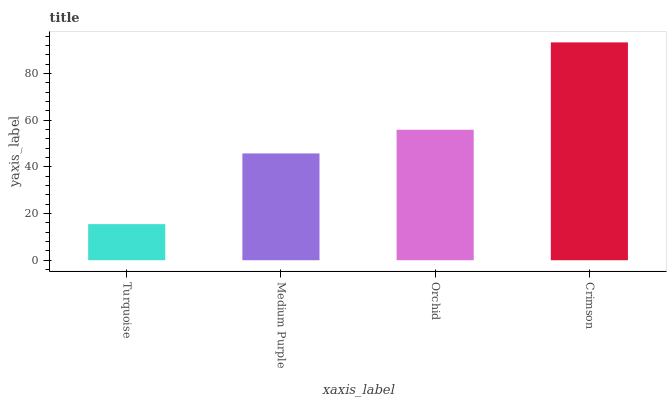Is Turquoise the minimum?
Answer yes or no. Yes. Is Crimson the maximum?
Answer yes or no. Yes. Is Medium Purple the minimum?
Answer yes or no. No. Is Medium Purple the maximum?
Answer yes or no. No. Is Medium Purple greater than Turquoise?
Answer yes or no. Yes. Is Turquoise less than Medium Purple?
Answer yes or no. Yes. Is Turquoise greater than Medium Purple?
Answer yes or no. No. Is Medium Purple less than Turquoise?
Answer yes or no. No. Is Orchid the high median?
Answer yes or no. Yes. Is Medium Purple the low median?
Answer yes or no. Yes. Is Medium Purple the high median?
Answer yes or no. No. Is Crimson the low median?
Answer yes or no. No. 